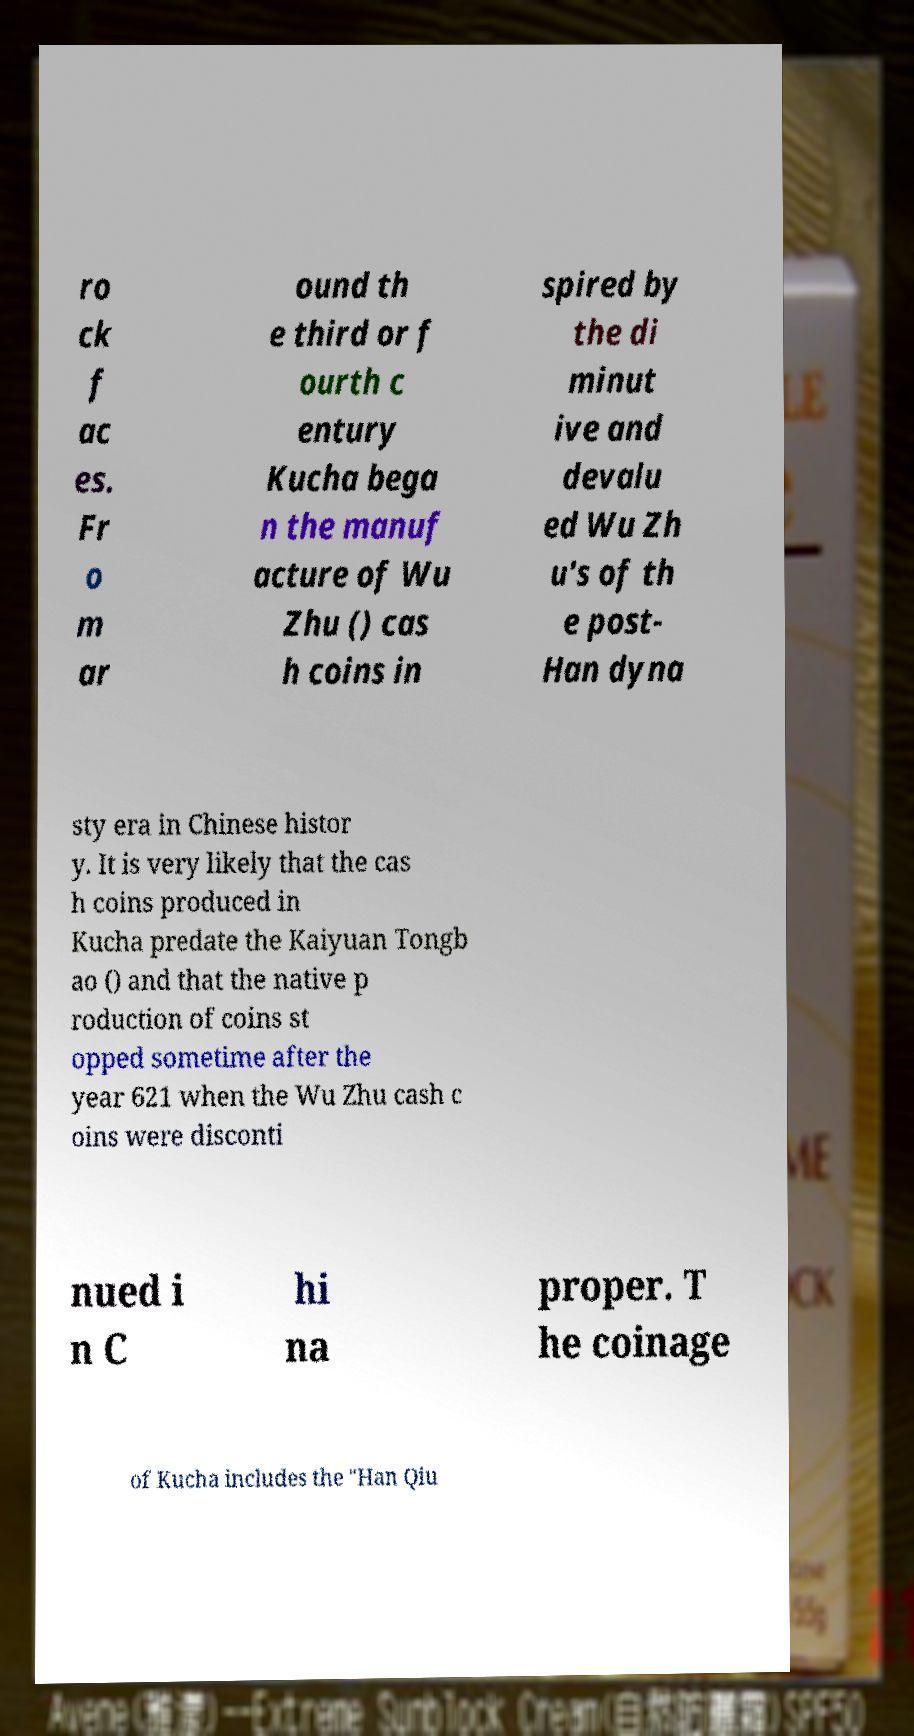What messages or text are displayed in this image? I need them in a readable, typed format. ro ck f ac es. Fr o m ar ound th e third or f ourth c entury Kucha bega n the manuf acture of Wu Zhu () cas h coins in spired by the di minut ive and devalu ed Wu Zh u's of th e post- Han dyna sty era in Chinese histor y. It is very likely that the cas h coins produced in Kucha predate the Kaiyuan Tongb ao () and that the native p roduction of coins st opped sometime after the year 621 when the Wu Zhu cash c oins were disconti nued i n C hi na proper. T he coinage of Kucha includes the "Han Qiu 